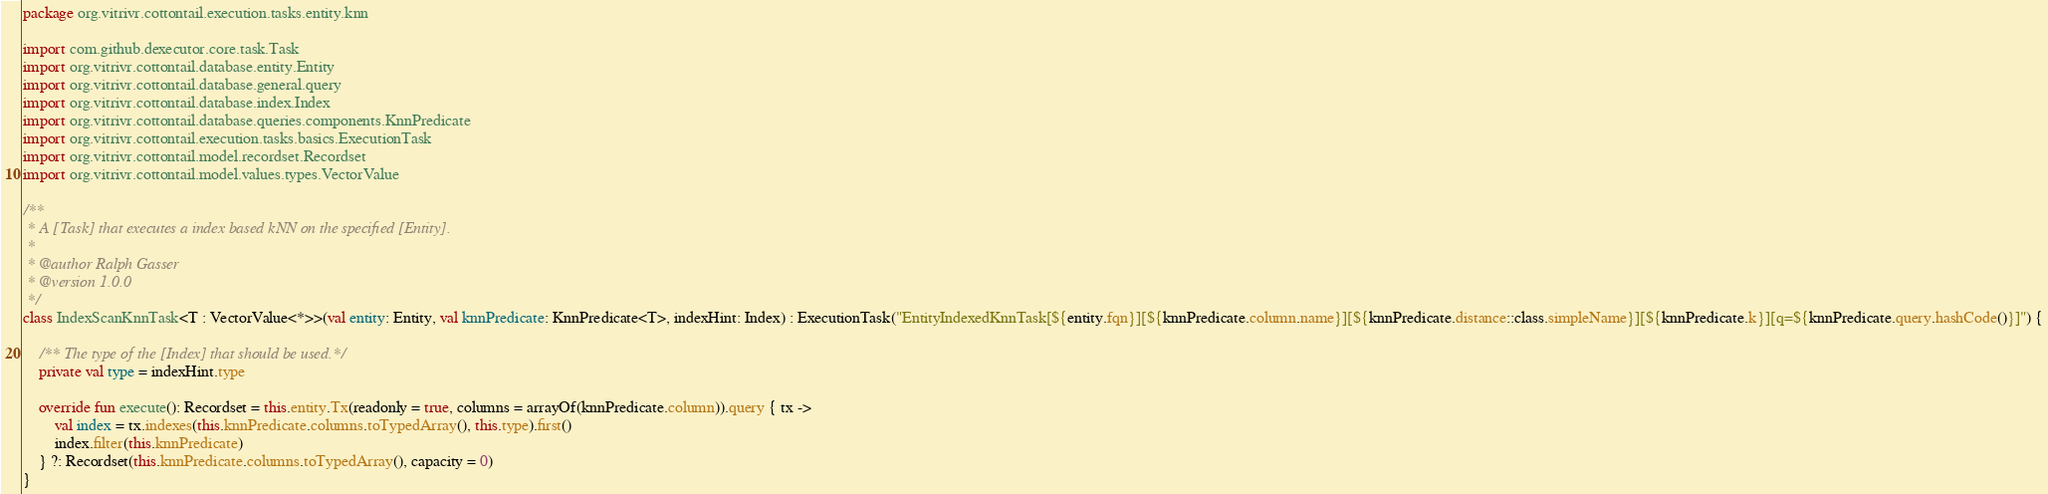Convert code to text. <code><loc_0><loc_0><loc_500><loc_500><_Kotlin_>package org.vitrivr.cottontail.execution.tasks.entity.knn

import com.github.dexecutor.core.task.Task
import org.vitrivr.cottontail.database.entity.Entity
import org.vitrivr.cottontail.database.general.query
import org.vitrivr.cottontail.database.index.Index
import org.vitrivr.cottontail.database.queries.components.KnnPredicate
import org.vitrivr.cottontail.execution.tasks.basics.ExecutionTask
import org.vitrivr.cottontail.model.recordset.Recordset
import org.vitrivr.cottontail.model.values.types.VectorValue

/**
 * A [Task] that executes a index based kNN on the specified [Entity].
 *
 * @author Ralph Gasser
 * @version 1.0.0
 */
class IndexScanKnnTask<T : VectorValue<*>>(val entity: Entity, val knnPredicate: KnnPredicate<T>, indexHint: Index) : ExecutionTask("EntityIndexedKnnTask[${entity.fqn}][${knnPredicate.column.name}][${knnPredicate.distance::class.simpleName}][${knnPredicate.k}][q=${knnPredicate.query.hashCode()}]") {

    /** The type of the [Index] that should be used.*/
    private val type = indexHint.type

    override fun execute(): Recordset = this.entity.Tx(readonly = true, columns = arrayOf(knnPredicate.column)).query { tx ->
        val index = tx.indexes(this.knnPredicate.columns.toTypedArray(), this.type).first()
        index.filter(this.knnPredicate)
    } ?: Recordset(this.knnPredicate.columns.toTypedArray(), capacity = 0)
}</code> 